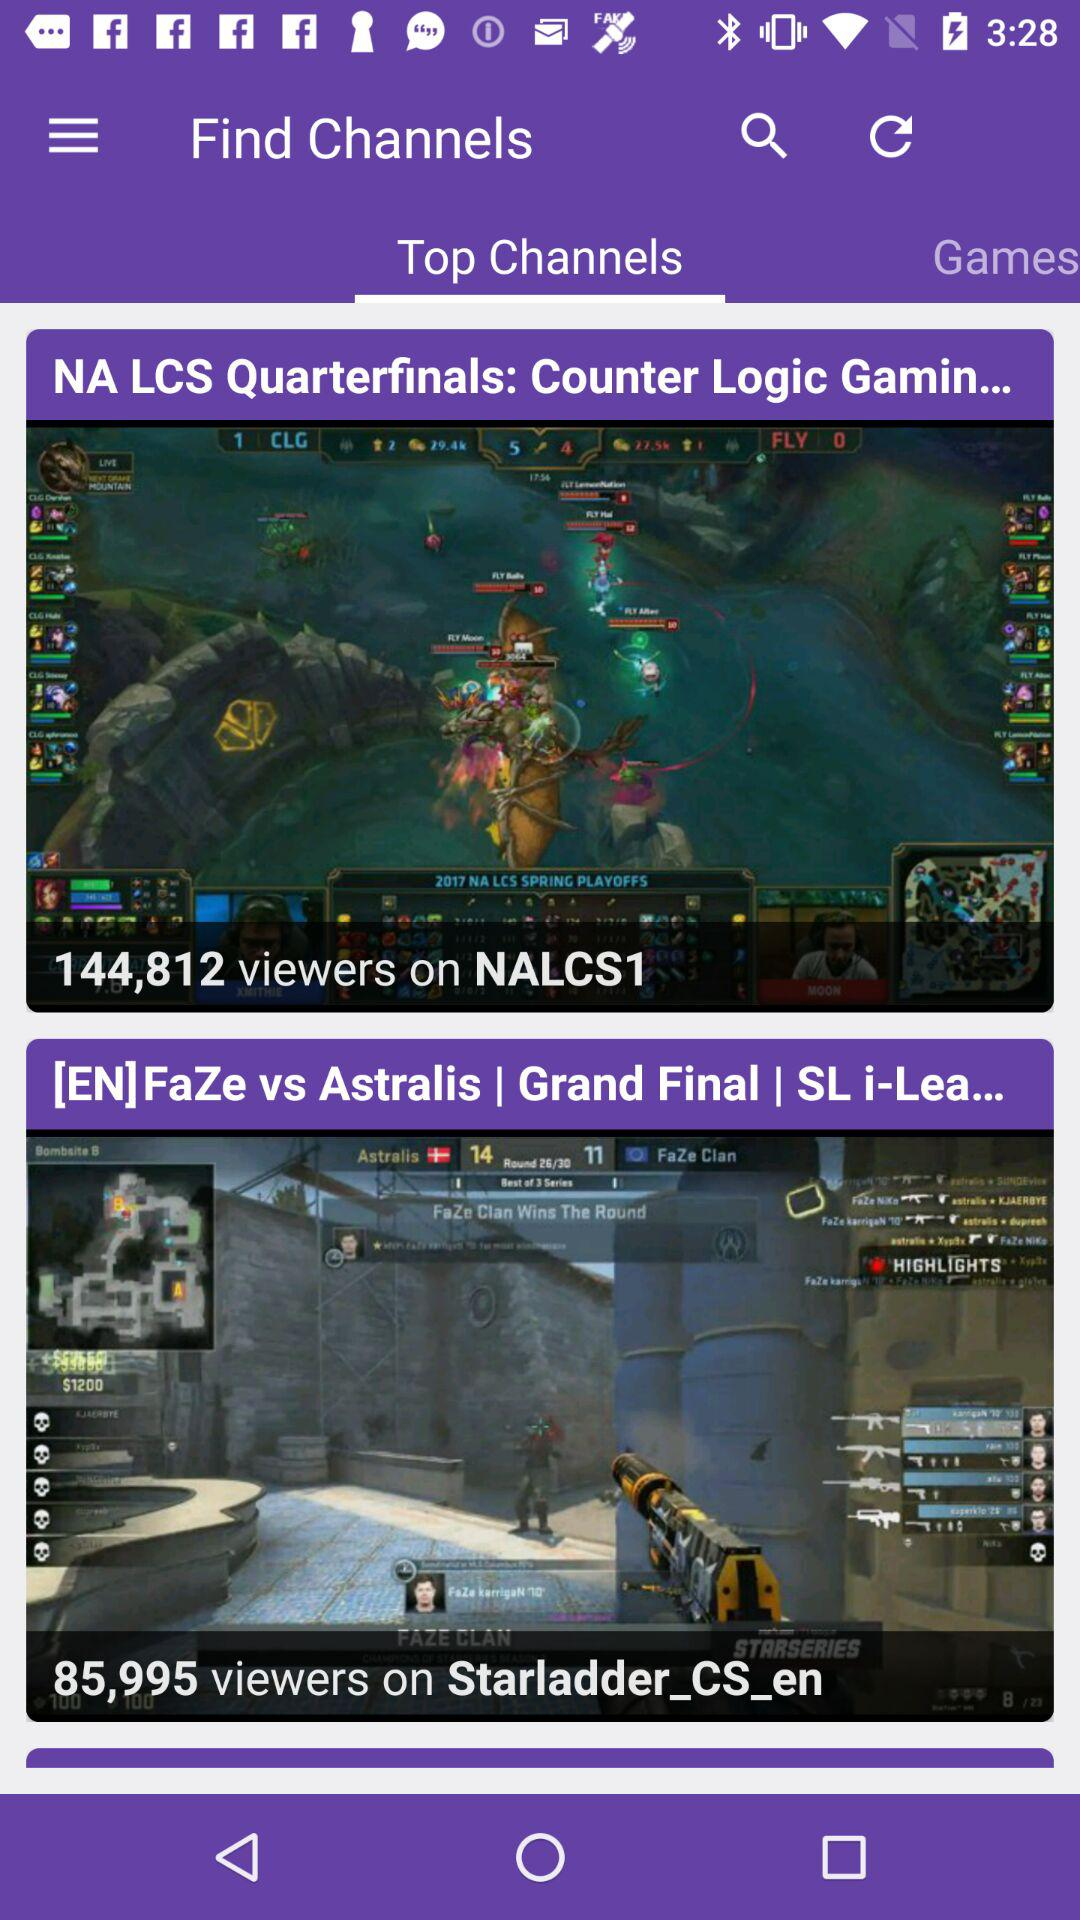What is the selected tab? The selected tab is "Top Channels". 